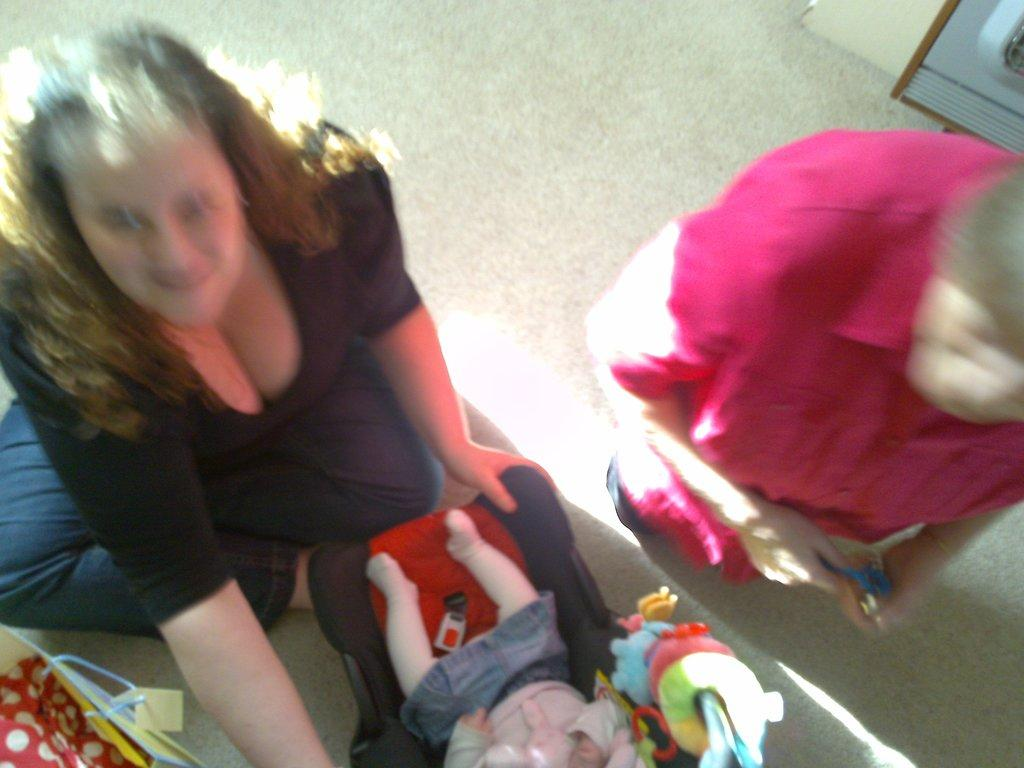How many people are in the image? There are two persons in the image. What is the person wearing a black and blue color dress doing? The information provided does not specify what the person is doing. What can be seen besides the two persons in the image? There is a toy baby and multicolored toys in the image. What type of flowers can be seen in the image? There are no flowers present in the image. 